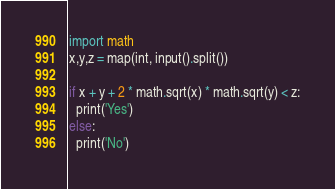Convert code to text. <code><loc_0><loc_0><loc_500><loc_500><_Python_>import math
x,y,z = map(int, input().split())
 
if x + y + 2 * math.sqrt(x) * math.sqrt(y) < z:
  print('Yes')
else:
  print('No')</code> 